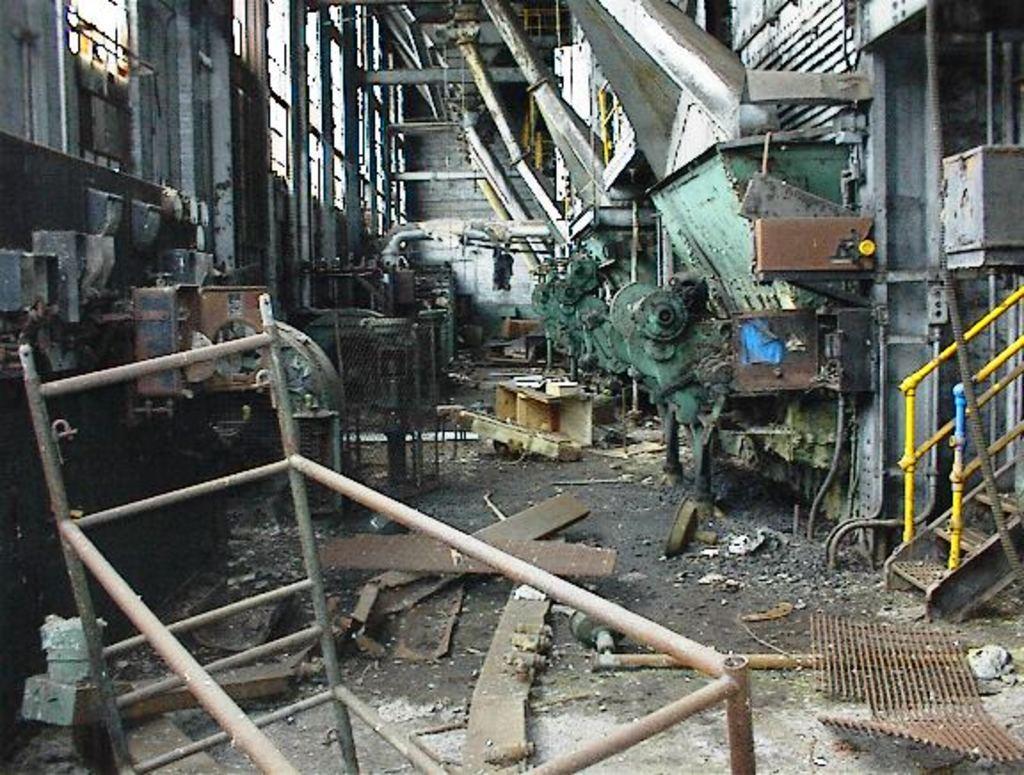In one or two sentences, can you explain what this image depicts? As we can see in the image, this is a mechanical factory and there are different types of electrical equipments and the place is very untidy and there are stairs over here. 